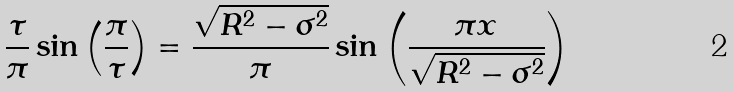Convert formula to latex. <formula><loc_0><loc_0><loc_500><loc_500>\frac { \tau } { \pi } \sin \left ( \frac { \pi } { \tau } \right ) = \frac { \sqrt { R ^ { 2 } - \sigma ^ { 2 } } } { \pi } \sin \left ( \frac { \pi x } { \sqrt { R ^ { 2 } - \sigma ^ { 2 } } } \right )</formula> 